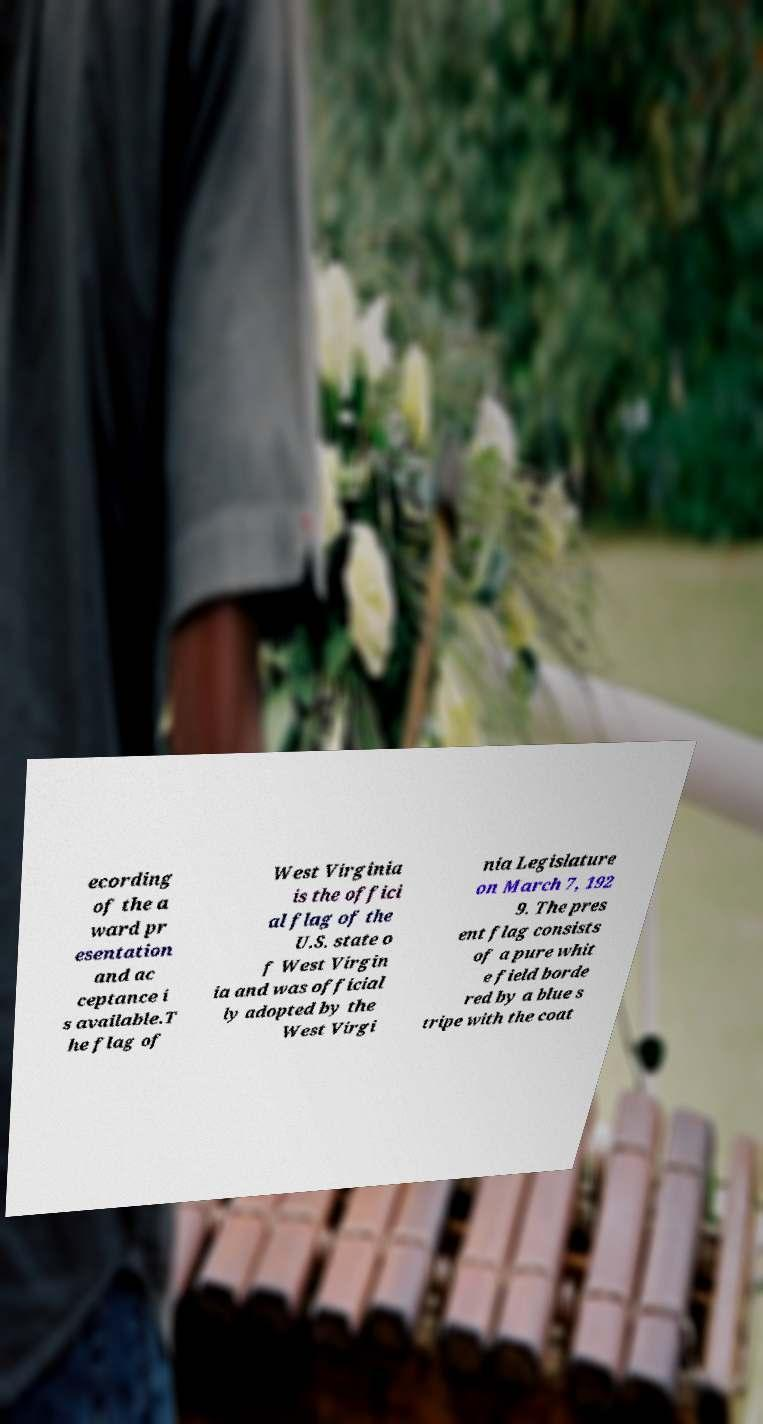Please read and relay the text visible in this image. What does it say? ecording of the a ward pr esentation and ac ceptance i s available.T he flag of West Virginia is the offici al flag of the U.S. state o f West Virgin ia and was official ly adopted by the West Virgi nia Legislature on March 7, 192 9. The pres ent flag consists of a pure whit e field borde red by a blue s tripe with the coat 